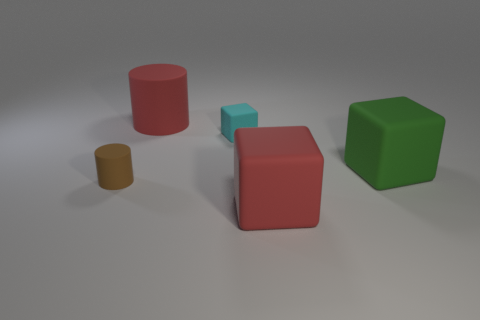Can you describe the arrangement of the objects in the image? Certainly! In the image, you'll see a collection of geometric shapes differently placed on a flat surface. There's a red cylinder standing upright, a smaller brown cylinder leaning against it, a green cube, and a red cube with a smaller cyan cube on top of it. The arrangement feels almost playful, as if testing the physics of how these objects can balance and interact with one another. 